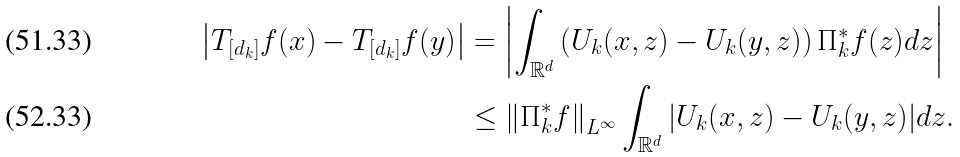Convert formula to latex. <formula><loc_0><loc_0><loc_500><loc_500>\left | T _ { [ d _ { k } ] } f ( x ) - T _ { [ d _ { k } ] } f ( y ) \right | & = \left | \int _ { \mathbb { R } ^ { d } } { \left ( U _ { k } ( x , z ) - U _ { k } ( y , z ) \right ) \Pi ^ { * } _ { k } f ( z ) } d z \right | \\ & \leq \left \| \Pi ^ { * } _ { k } f \right \| _ { L ^ { \infty } } \int _ { \mathbb { R } ^ { d } } { \left | U _ { k } ( x , z ) - U _ { k } ( y , z ) \right | } d z .</formula> 